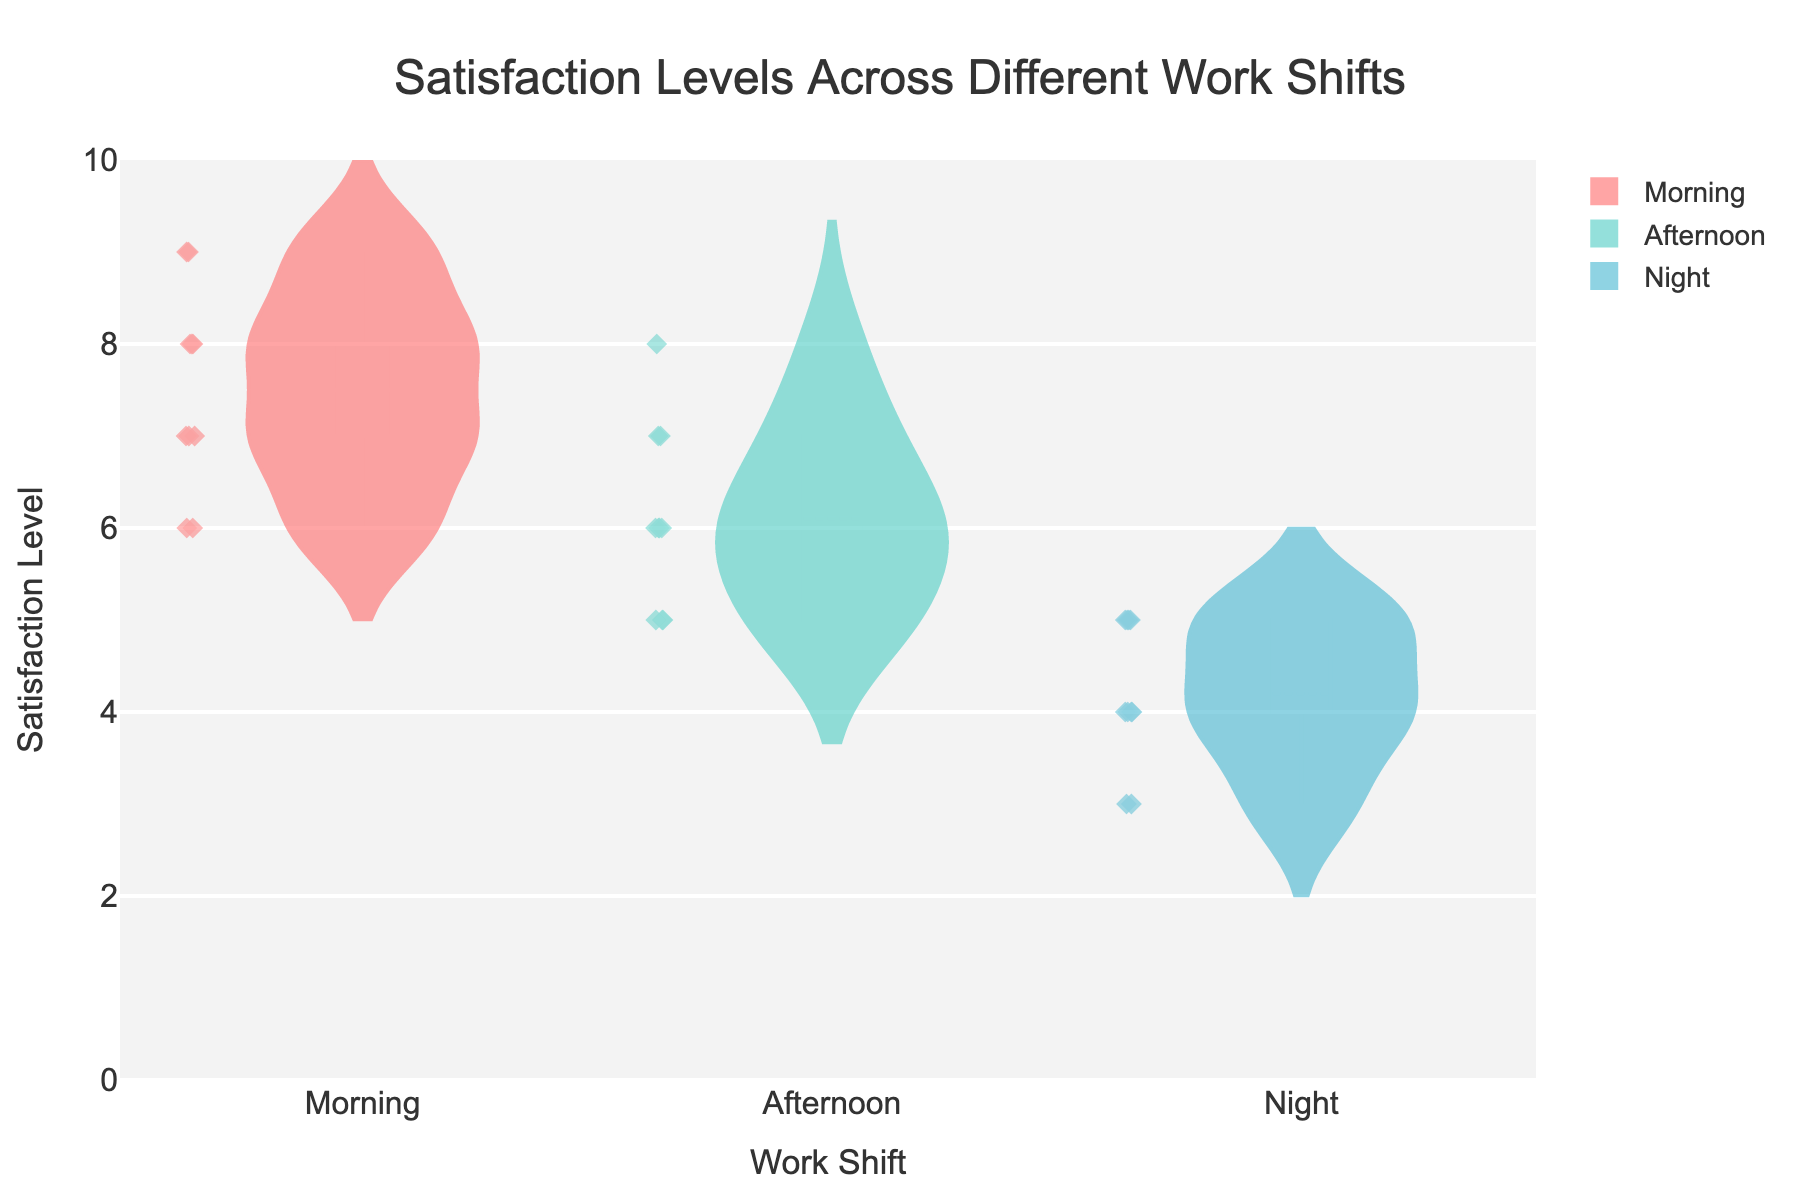What is the title of the figure? The title of the figure can be found at the top and clearly states what the entire plot is representing. Here, the title is "Satisfaction Levels Across Different Work Shifts".
Answer: Satisfaction Levels Across Different Work Shifts Which shift has the highest median satisfaction level? We can find the median satisfaction level by looking at the middle line in the box plot overlay within each violin plot. For the Morning shift, this line is at 7.5, for the Afternoon shift it's at 6, and for the Night shift, it's at 4.5. Therefore, the Morning shift has the highest median satisfaction level.
Answer: Morning What is the average satisfaction level for the Morning shift? To find the average, we sum all the satisfaction levels for the Morning shift and divide by the number of data points. The Morning shift has values 7, 6, 8, 7, 9, 8, 6, 7, 8, 9. The sum is 75 and there are 10 data points, so the average is 75 / 10.
Answer: 7.5 Which shift has the most variability in satisfaction levels? By examining the width of the violin plots and the spread of the box plots, the Night shift has the most variability because its satisfaction levels range from 3 to 5. The Morning and Afternoon shifts have relatively less spread in their data.
Answer: Night How many data points are there for the Afternoon shift? The number of data points can be identified by the scattered points within the violin plot. For the Afternoon shift, there are 10 points.
Answer: 10 What is the range of satisfaction levels for the Night shift? The range can be found by looking at the minimum and maximum points in the violin plot for the Night shift. The minimum is 3 and the maximum is 5.
Answer: 2 Compare the highest satisfaction score across all shifts. The maximum satisfaction levels are the topmost points in each violin plot. Morning and Afternoon shifts both have a maximum of 9 and 8 respectively. The Night shift has a maximum of 5. Therefore, Morning shift has the highest maximum satisfaction score.
Answer: Morning What is the interquartile range (IQR) for the Afternoon shift? The IQR is calculated by subtracting the first quartile (Q1) from the third quartile (Q3). In the box plot for Afternoon, Q1 is 5.5 and Q3 is 7.0. So, the IQR is 7.0 - 5.5.
Answer: 1.5 Which shift has the lowest mean satisfaction level? The mean is represented by the dashed line in each violin plot. For the Morning shift, it's around 7.5, for the Afternoon shift it's around 6.1, and for the Night shift, it's around 4.2. Therefore, the Night shift has the lowest mean satisfaction level.
Answer: Night 